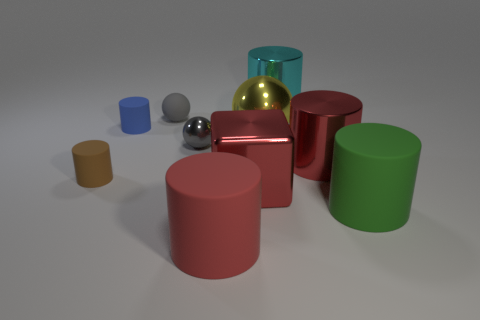What is the reflection seen in the sphere to the right of the red cube? The reflection in the sphere to the right of the red cube shows a distorted image of the surrounding objects, capturing the curves of the cylinders and the surrounding room. It highlights the reflective nature of the material the sphere is made from. 